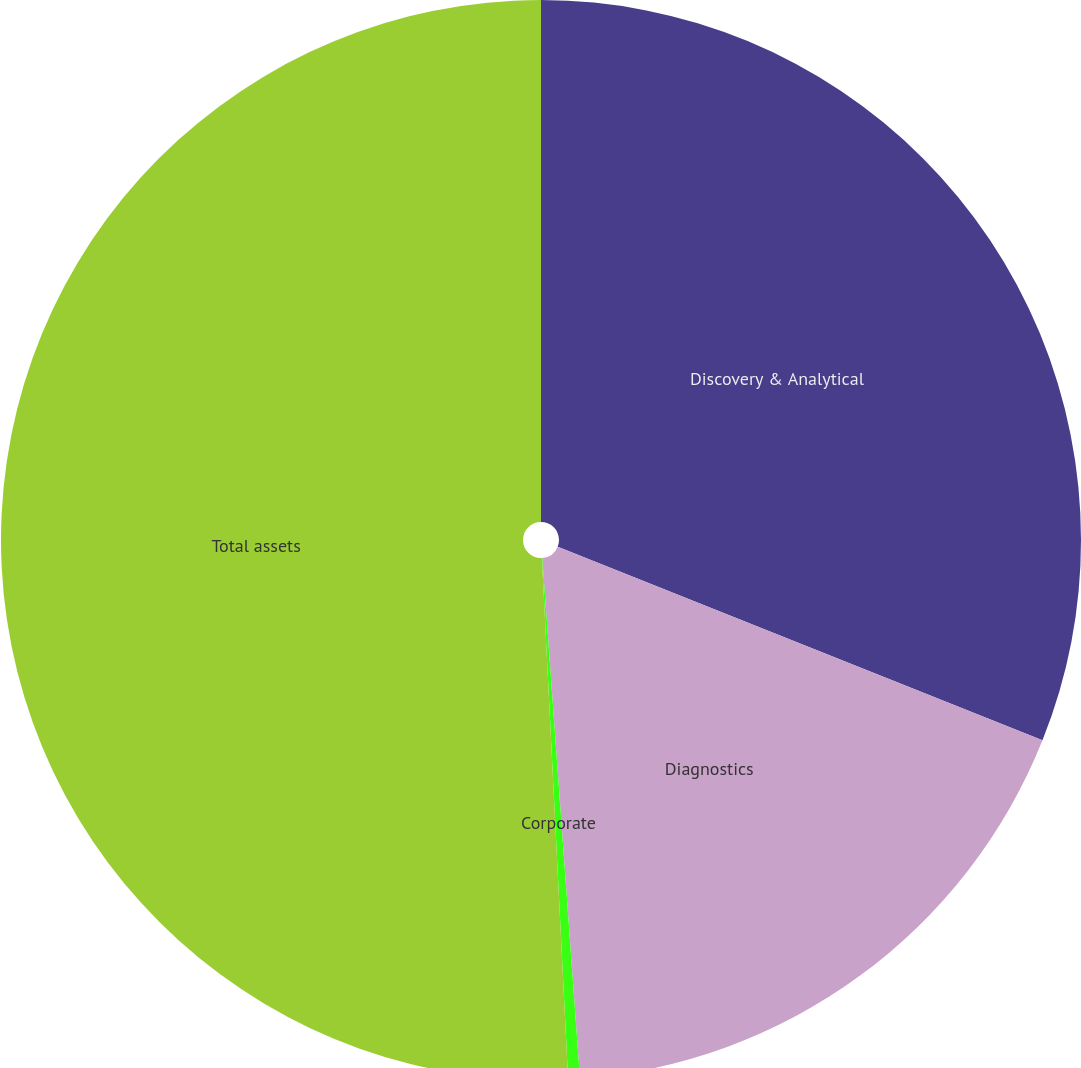Convert chart. <chart><loc_0><loc_0><loc_500><loc_500><pie_chart><fcel>Discovery & Analytical<fcel>Diagnostics<fcel>Corporate<fcel>Total assets<nl><fcel>31.05%<fcel>17.8%<fcel>0.35%<fcel>50.8%<nl></chart> 